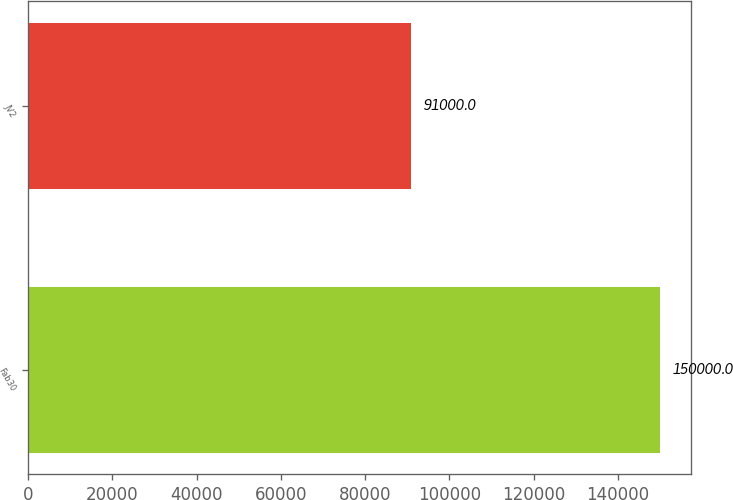<chart> <loc_0><loc_0><loc_500><loc_500><bar_chart><fcel>Fab30<fcel>JV2<nl><fcel>150000<fcel>91000<nl></chart> 